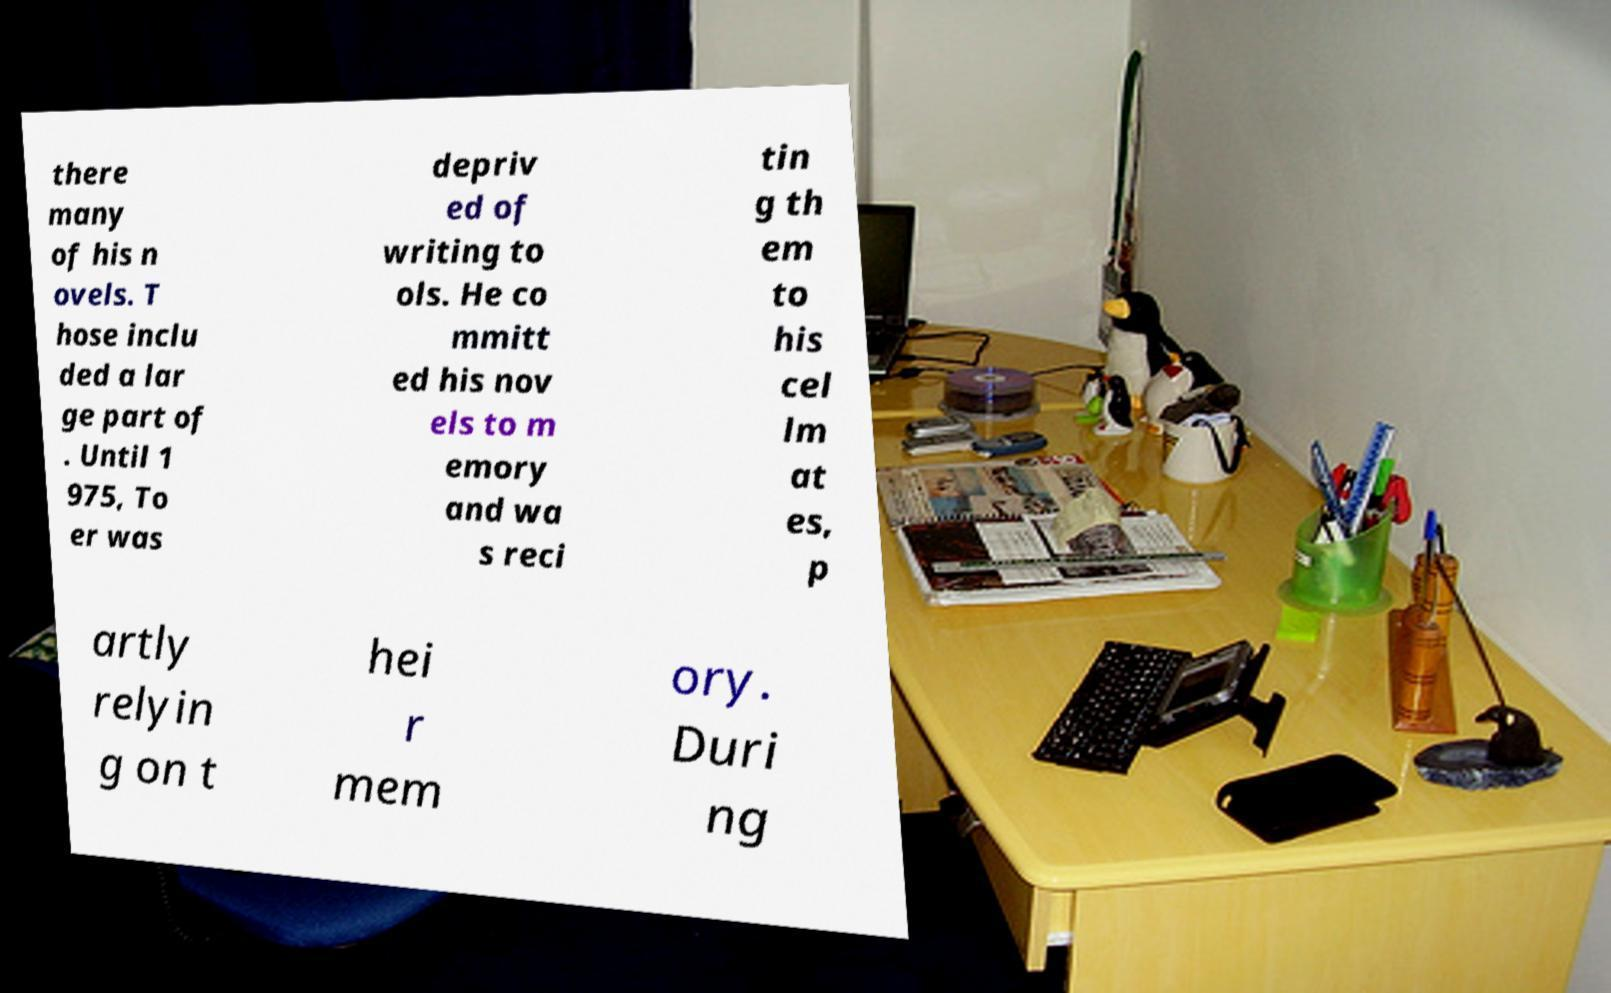Please identify and transcribe the text found in this image. there many of his n ovels. T hose inclu ded a lar ge part of . Until 1 975, To er was depriv ed of writing to ols. He co mmitt ed his nov els to m emory and wa s reci tin g th em to his cel lm at es, p artly relyin g on t hei r mem ory. Duri ng 